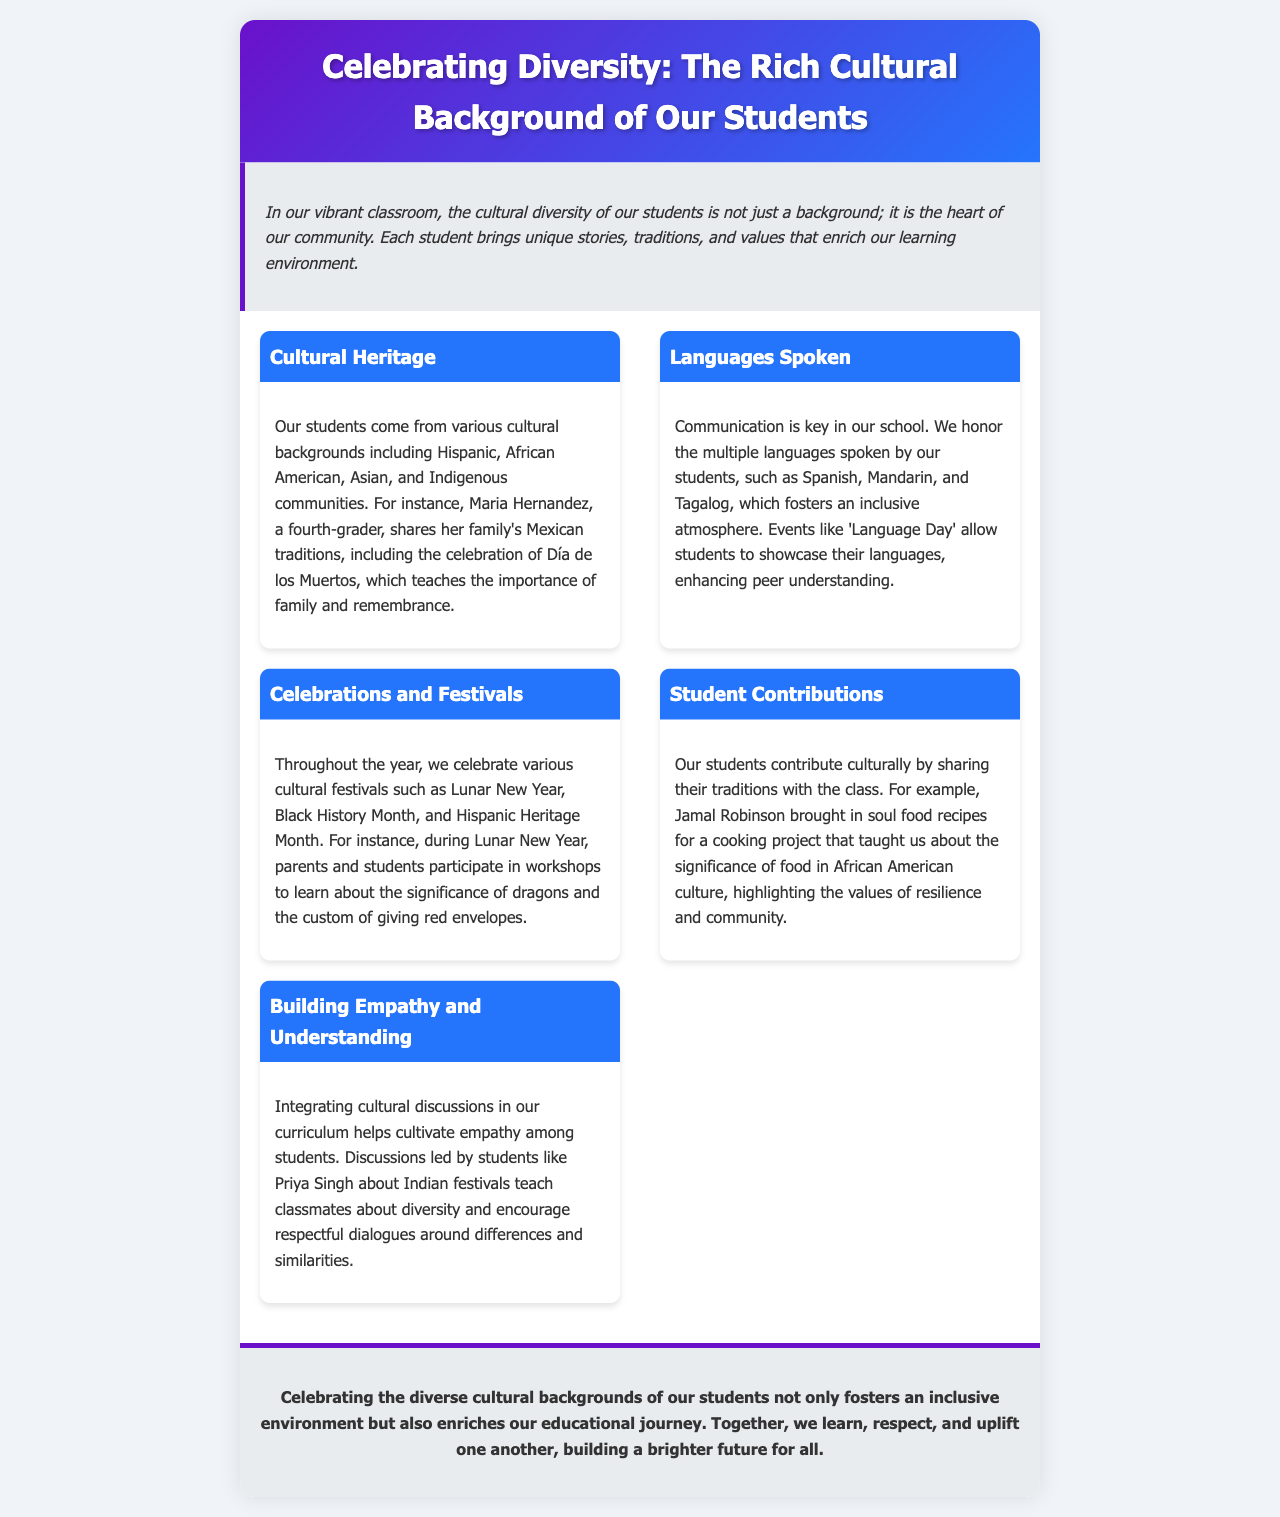What is the title of the brochure? The title is prominently displayed at the top of the document and states the focus of the brochure.
Answer: Celebrating Diversity: The Rich Cultural Background of Our Students Who shares Mexican traditions in the brochure? The document mentions a specific student that shares her family's cultural traditions, highlighting the importance of family and remembrance.
Answer: Maria Hernandez Which languages are honored in the school? The section discusses multiple languages and gives examples of those spoken by students to promote inclusivity.
Answer: Spanish, Mandarin, and Tagalog What festival is celebrated during Lunar New Year? The brochure highlights what is taught during the celebration of Lunar New Year and the customs that are practiced.
Answer: Significance of dragons and the custom of giving red envelopes Who contributed soul food recipes for a project? The document provides an example of a student sharing their cultural heritage through food, emphasizing a specific student's contribution.
Answer: Jamal Robinson What is the purpose of integrating cultural discussions in the curriculum? This reasoning question connects the information given about the need for empathy and understanding through discussions.
Answer: Cultivate empathy What themes are explored during Black History Month? The brochure states the educational focus during Black History Month and fosters discussions around cultural diversity.
Answer: Cultural diversity What is celebrated alongside Hispanic Heritage Month? The document mentions various festivals throughout the year that are commemorated in class.
Answer: Various cultural festivals What is the overall goal of celebrating diversity according to the brochure? The conclusion encapsulates the broader impact of cultural celebrations in the educational journey and community engagement.
Answer: Enriches our educational journey 